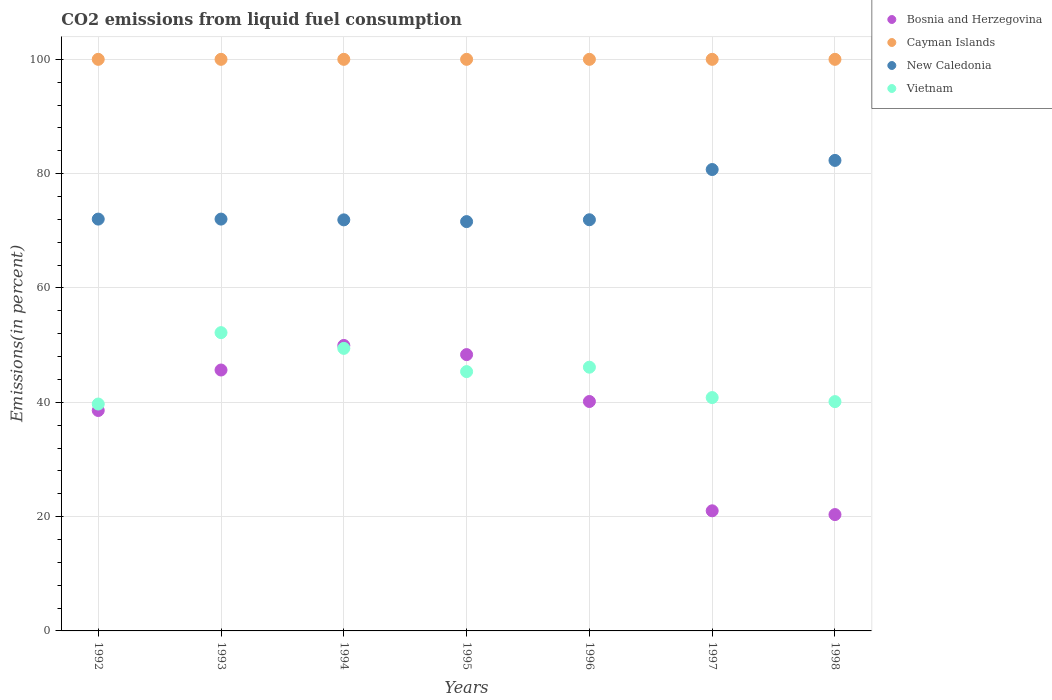Is the number of dotlines equal to the number of legend labels?
Offer a terse response. Yes. What is the total CO2 emitted in Bosnia and Herzegovina in 1996?
Your response must be concise. 40.14. Across all years, what is the maximum total CO2 emitted in Cayman Islands?
Provide a succinct answer. 100. Across all years, what is the minimum total CO2 emitted in Vietnam?
Your response must be concise. 39.7. In which year was the total CO2 emitted in New Caledonia maximum?
Provide a succinct answer. 1998. In which year was the total CO2 emitted in Cayman Islands minimum?
Provide a short and direct response. 1992. What is the total total CO2 emitted in New Caledonia in the graph?
Offer a very short reply. 522.6. What is the difference between the total CO2 emitted in New Caledonia in 1994 and that in 1995?
Make the answer very short. 0.3. What is the difference between the total CO2 emitted in Bosnia and Herzegovina in 1992 and the total CO2 emitted in Cayman Islands in 1996?
Provide a short and direct response. -61.44. What is the average total CO2 emitted in Bosnia and Herzegovina per year?
Your answer should be compact. 37.71. In the year 1992, what is the difference between the total CO2 emitted in New Caledonia and total CO2 emitted in Vietnam?
Keep it short and to the point. 32.35. In how many years, is the total CO2 emitted in Bosnia and Herzegovina greater than 72 %?
Provide a short and direct response. 0. What is the ratio of the total CO2 emitted in Vietnam in 1995 to that in 1996?
Offer a very short reply. 0.98. What is the difference between the highest and the second highest total CO2 emitted in Vietnam?
Make the answer very short. 2.75. What is the difference between the highest and the lowest total CO2 emitted in New Caledonia?
Offer a terse response. 10.71. Does the total CO2 emitted in New Caledonia monotonically increase over the years?
Your response must be concise. No. What is the difference between two consecutive major ticks on the Y-axis?
Offer a terse response. 20. How are the legend labels stacked?
Make the answer very short. Vertical. What is the title of the graph?
Offer a terse response. CO2 emissions from liquid fuel consumption. Does "Liechtenstein" appear as one of the legend labels in the graph?
Offer a very short reply. No. What is the label or title of the Y-axis?
Keep it short and to the point. Emissions(in percent). What is the Emissions(in percent) of Bosnia and Herzegovina in 1992?
Offer a very short reply. 38.56. What is the Emissions(in percent) of New Caledonia in 1992?
Provide a succinct answer. 72.05. What is the Emissions(in percent) of Vietnam in 1992?
Your answer should be compact. 39.7. What is the Emissions(in percent) of Bosnia and Herzegovina in 1993?
Keep it short and to the point. 45.65. What is the Emissions(in percent) of Cayman Islands in 1993?
Your response must be concise. 100. What is the Emissions(in percent) in New Caledonia in 1993?
Your answer should be very brief. 72.05. What is the Emissions(in percent) of Vietnam in 1993?
Give a very brief answer. 52.18. What is the Emissions(in percent) in Bosnia and Herzegovina in 1994?
Your response must be concise. 49.94. What is the Emissions(in percent) of New Caledonia in 1994?
Your answer should be very brief. 71.91. What is the Emissions(in percent) of Vietnam in 1994?
Offer a terse response. 49.43. What is the Emissions(in percent) in Bosnia and Herzegovina in 1995?
Ensure brevity in your answer.  48.34. What is the Emissions(in percent) in New Caledonia in 1995?
Give a very brief answer. 71.61. What is the Emissions(in percent) in Vietnam in 1995?
Your answer should be compact. 45.37. What is the Emissions(in percent) in Bosnia and Herzegovina in 1996?
Make the answer very short. 40.14. What is the Emissions(in percent) of Cayman Islands in 1996?
Keep it short and to the point. 100. What is the Emissions(in percent) of New Caledonia in 1996?
Make the answer very short. 71.93. What is the Emissions(in percent) in Vietnam in 1996?
Keep it short and to the point. 46.14. What is the Emissions(in percent) in Bosnia and Herzegovina in 1997?
Your answer should be compact. 21.01. What is the Emissions(in percent) of Cayman Islands in 1997?
Keep it short and to the point. 100. What is the Emissions(in percent) in New Caledonia in 1997?
Offer a terse response. 80.72. What is the Emissions(in percent) of Vietnam in 1997?
Ensure brevity in your answer.  40.82. What is the Emissions(in percent) of Bosnia and Herzegovina in 1998?
Provide a short and direct response. 20.35. What is the Emissions(in percent) of Cayman Islands in 1998?
Offer a very short reply. 100. What is the Emissions(in percent) of New Caledonia in 1998?
Your answer should be very brief. 82.32. What is the Emissions(in percent) of Vietnam in 1998?
Give a very brief answer. 40.12. Across all years, what is the maximum Emissions(in percent) in Bosnia and Herzegovina?
Keep it short and to the point. 49.94. Across all years, what is the maximum Emissions(in percent) of New Caledonia?
Offer a very short reply. 82.32. Across all years, what is the maximum Emissions(in percent) of Vietnam?
Your response must be concise. 52.18. Across all years, what is the minimum Emissions(in percent) of Bosnia and Herzegovina?
Your answer should be very brief. 20.35. Across all years, what is the minimum Emissions(in percent) in New Caledonia?
Give a very brief answer. 71.61. Across all years, what is the minimum Emissions(in percent) of Vietnam?
Your answer should be very brief. 39.7. What is the total Emissions(in percent) in Bosnia and Herzegovina in the graph?
Your response must be concise. 264. What is the total Emissions(in percent) in Cayman Islands in the graph?
Offer a terse response. 700. What is the total Emissions(in percent) in New Caledonia in the graph?
Ensure brevity in your answer.  522.6. What is the total Emissions(in percent) of Vietnam in the graph?
Your response must be concise. 313.76. What is the difference between the Emissions(in percent) of Bosnia and Herzegovina in 1992 and that in 1993?
Your response must be concise. -7.08. What is the difference between the Emissions(in percent) of Vietnam in 1992 and that in 1993?
Give a very brief answer. -12.49. What is the difference between the Emissions(in percent) of Bosnia and Herzegovina in 1992 and that in 1994?
Make the answer very short. -11.38. What is the difference between the Emissions(in percent) of New Caledonia in 1992 and that in 1994?
Offer a very short reply. 0.13. What is the difference between the Emissions(in percent) of Vietnam in 1992 and that in 1994?
Your answer should be very brief. -9.74. What is the difference between the Emissions(in percent) in Bosnia and Herzegovina in 1992 and that in 1995?
Provide a succinct answer. -9.78. What is the difference between the Emissions(in percent) in Cayman Islands in 1992 and that in 1995?
Give a very brief answer. 0. What is the difference between the Emissions(in percent) in New Caledonia in 1992 and that in 1995?
Ensure brevity in your answer.  0.44. What is the difference between the Emissions(in percent) of Vietnam in 1992 and that in 1995?
Offer a very short reply. -5.67. What is the difference between the Emissions(in percent) in Bosnia and Herzegovina in 1992 and that in 1996?
Your answer should be compact. -1.57. What is the difference between the Emissions(in percent) in New Caledonia in 1992 and that in 1996?
Your answer should be very brief. 0.12. What is the difference between the Emissions(in percent) in Vietnam in 1992 and that in 1996?
Provide a short and direct response. -6.44. What is the difference between the Emissions(in percent) of Bosnia and Herzegovina in 1992 and that in 1997?
Make the answer very short. 17.55. What is the difference between the Emissions(in percent) in New Caledonia in 1992 and that in 1997?
Offer a very short reply. -8.67. What is the difference between the Emissions(in percent) of Vietnam in 1992 and that in 1997?
Your response must be concise. -1.13. What is the difference between the Emissions(in percent) of Bosnia and Herzegovina in 1992 and that in 1998?
Your answer should be compact. 18.21. What is the difference between the Emissions(in percent) in Cayman Islands in 1992 and that in 1998?
Provide a succinct answer. 0. What is the difference between the Emissions(in percent) in New Caledonia in 1992 and that in 1998?
Provide a succinct answer. -10.27. What is the difference between the Emissions(in percent) of Vietnam in 1992 and that in 1998?
Offer a terse response. -0.42. What is the difference between the Emissions(in percent) in Bosnia and Herzegovina in 1993 and that in 1994?
Make the answer very short. -4.3. What is the difference between the Emissions(in percent) of New Caledonia in 1993 and that in 1994?
Your response must be concise. 0.13. What is the difference between the Emissions(in percent) of Vietnam in 1993 and that in 1994?
Keep it short and to the point. 2.75. What is the difference between the Emissions(in percent) in Bosnia and Herzegovina in 1993 and that in 1995?
Provide a short and direct response. -2.7. What is the difference between the Emissions(in percent) of Cayman Islands in 1993 and that in 1995?
Provide a short and direct response. 0. What is the difference between the Emissions(in percent) of New Caledonia in 1993 and that in 1995?
Provide a succinct answer. 0.44. What is the difference between the Emissions(in percent) in Vietnam in 1993 and that in 1995?
Keep it short and to the point. 6.82. What is the difference between the Emissions(in percent) in Bosnia and Herzegovina in 1993 and that in 1996?
Provide a succinct answer. 5.51. What is the difference between the Emissions(in percent) in New Caledonia in 1993 and that in 1996?
Make the answer very short. 0.12. What is the difference between the Emissions(in percent) of Vietnam in 1993 and that in 1996?
Keep it short and to the point. 6.04. What is the difference between the Emissions(in percent) of Bosnia and Herzegovina in 1993 and that in 1997?
Provide a short and direct response. 24.63. What is the difference between the Emissions(in percent) in Cayman Islands in 1993 and that in 1997?
Make the answer very short. 0. What is the difference between the Emissions(in percent) of New Caledonia in 1993 and that in 1997?
Offer a very short reply. -8.67. What is the difference between the Emissions(in percent) of Vietnam in 1993 and that in 1997?
Offer a very short reply. 11.36. What is the difference between the Emissions(in percent) in Bosnia and Herzegovina in 1993 and that in 1998?
Ensure brevity in your answer.  25.29. What is the difference between the Emissions(in percent) in New Caledonia in 1993 and that in 1998?
Your answer should be very brief. -10.27. What is the difference between the Emissions(in percent) of Vietnam in 1993 and that in 1998?
Give a very brief answer. 12.07. What is the difference between the Emissions(in percent) in Bosnia and Herzegovina in 1994 and that in 1995?
Provide a succinct answer. 1.6. What is the difference between the Emissions(in percent) of New Caledonia in 1994 and that in 1995?
Give a very brief answer. 0.3. What is the difference between the Emissions(in percent) of Vietnam in 1994 and that in 1995?
Provide a succinct answer. 4.07. What is the difference between the Emissions(in percent) of Bosnia and Herzegovina in 1994 and that in 1996?
Your answer should be compact. 9.81. What is the difference between the Emissions(in percent) in Cayman Islands in 1994 and that in 1996?
Ensure brevity in your answer.  0. What is the difference between the Emissions(in percent) of New Caledonia in 1994 and that in 1996?
Make the answer very short. -0.02. What is the difference between the Emissions(in percent) of Vietnam in 1994 and that in 1996?
Your answer should be compact. 3.29. What is the difference between the Emissions(in percent) of Bosnia and Herzegovina in 1994 and that in 1997?
Give a very brief answer. 28.93. What is the difference between the Emissions(in percent) in Cayman Islands in 1994 and that in 1997?
Your answer should be compact. 0. What is the difference between the Emissions(in percent) of New Caledonia in 1994 and that in 1997?
Your answer should be very brief. -8.81. What is the difference between the Emissions(in percent) in Vietnam in 1994 and that in 1997?
Provide a short and direct response. 8.61. What is the difference between the Emissions(in percent) of Bosnia and Herzegovina in 1994 and that in 1998?
Offer a very short reply. 29.59. What is the difference between the Emissions(in percent) in New Caledonia in 1994 and that in 1998?
Provide a short and direct response. -10.4. What is the difference between the Emissions(in percent) in Vietnam in 1994 and that in 1998?
Offer a very short reply. 9.32. What is the difference between the Emissions(in percent) in Bosnia and Herzegovina in 1995 and that in 1996?
Ensure brevity in your answer.  8.2. What is the difference between the Emissions(in percent) in Cayman Islands in 1995 and that in 1996?
Offer a very short reply. 0. What is the difference between the Emissions(in percent) of New Caledonia in 1995 and that in 1996?
Give a very brief answer. -0.32. What is the difference between the Emissions(in percent) in Vietnam in 1995 and that in 1996?
Your response must be concise. -0.77. What is the difference between the Emissions(in percent) of Bosnia and Herzegovina in 1995 and that in 1997?
Offer a very short reply. 27.33. What is the difference between the Emissions(in percent) in New Caledonia in 1995 and that in 1997?
Give a very brief answer. -9.11. What is the difference between the Emissions(in percent) in Vietnam in 1995 and that in 1997?
Your answer should be compact. 4.54. What is the difference between the Emissions(in percent) of Bosnia and Herzegovina in 1995 and that in 1998?
Make the answer very short. 27.99. What is the difference between the Emissions(in percent) of New Caledonia in 1995 and that in 1998?
Your answer should be very brief. -10.71. What is the difference between the Emissions(in percent) in Vietnam in 1995 and that in 1998?
Your response must be concise. 5.25. What is the difference between the Emissions(in percent) of Bosnia and Herzegovina in 1996 and that in 1997?
Offer a terse response. 19.12. What is the difference between the Emissions(in percent) in New Caledonia in 1996 and that in 1997?
Your response must be concise. -8.79. What is the difference between the Emissions(in percent) of Vietnam in 1996 and that in 1997?
Offer a very short reply. 5.31. What is the difference between the Emissions(in percent) in Bosnia and Herzegovina in 1996 and that in 1998?
Ensure brevity in your answer.  19.78. What is the difference between the Emissions(in percent) in New Caledonia in 1996 and that in 1998?
Ensure brevity in your answer.  -10.38. What is the difference between the Emissions(in percent) of Vietnam in 1996 and that in 1998?
Your response must be concise. 6.02. What is the difference between the Emissions(in percent) of Bosnia and Herzegovina in 1997 and that in 1998?
Make the answer very short. 0.66. What is the difference between the Emissions(in percent) of Cayman Islands in 1997 and that in 1998?
Offer a terse response. 0. What is the difference between the Emissions(in percent) of New Caledonia in 1997 and that in 1998?
Make the answer very short. -1.59. What is the difference between the Emissions(in percent) of Vietnam in 1997 and that in 1998?
Ensure brevity in your answer.  0.71. What is the difference between the Emissions(in percent) in Bosnia and Herzegovina in 1992 and the Emissions(in percent) in Cayman Islands in 1993?
Your answer should be compact. -61.44. What is the difference between the Emissions(in percent) of Bosnia and Herzegovina in 1992 and the Emissions(in percent) of New Caledonia in 1993?
Your response must be concise. -33.49. What is the difference between the Emissions(in percent) of Bosnia and Herzegovina in 1992 and the Emissions(in percent) of Vietnam in 1993?
Offer a terse response. -13.62. What is the difference between the Emissions(in percent) in Cayman Islands in 1992 and the Emissions(in percent) in New Caledonia in 1993?
Offer a terse response. 27.95. What is the difference between the Emissions(in percent) of Cayman Islands in 1992 and the Emissions(in percent) of Vietnam in 1993?
Offer a very short reply. 47.82. What is the difference between the Emissions(in percent) of New Caledonia in 1992 and the Emissions(in percent) of Vietnam in 1993?
Make the answer very short. 19.87. What is the difference between the Emissions(in percent) of Bosnia and Herzegovina in 1992 and the Emissions(in percent) of Cayman Islands in 1994?
Keep it short and to the point. -61.44. What is the difference between the Emissions(in percent) in Bosnia and Herzegovina in 1992 and the Emissions(in percent) in New Caledonia in 1994?
Ensure brevity in your answer.  -33.35. What is the difference between the Emissions(in percent) of Bosnia and Herzegovina in 1992 and the Emissions(in percent) of Vietnam in 1994?
Offer a very short reply. -10.87. What is the difference between the Emissions(in percent) of Cayman Islands in 1992 and the Emissions(in percent) of New Caledonia in 1994?
Give a very brief answer. 28.09. What is the difference between the Emissions(in percent) in Cayman Islands in 1992 and the Emissions(in percent) in Vietnam in 1994?
Your answer should be very brief. 50.57. What is the difference between the Emissions(in percent) in New Caledonia in 1992 and the Emissions(in percent) in Vietnam in 1994?
Provide a short and direct response. 22.62. What is the difference between the Emissions(in percent) of Bosnia and Herzegovina in 1992 and the Emissions(in percent) of Cayman Islands in 1995?
Offer a very short reply. -61.44. What is the difference between the Emissions(in percent) in Bosnia and Herzegovina in 1992 and the Emissions(in percent) in New Caledonia in 1995?
Offer a very short reply. -33.05. What is the difference between the Emissions(in percent) of Bosnia and Herzegovina in 1992 and the Emissions(in percent) of Vietnam in 1995?
Your response must be concise. -6.8. What is the difference between the Emissions(in percent) of Cayman Islands in 1992 and the Emissions(in percent) of New Caledonia in 1995?
Ensure brevity in your answer.  28.39. What is the difference between the Emissions(in percent) in Cayman Islands in 1992 and the Emissions(in percent) in Vietnam in 1995?
Provide a succinct answer. 54.63. What is the difference between the Emissions(in percent) in New Caledonia in 1992 and the Emissions(in percent) in Vietnam in 1995?
Offer a very short reply. 26.68. What is the difference between the Emissions(in percent) in Bosnia and Herzegovina in 1992 and the Emissions(in percent) in Cayman Islands in 1996?
Offer a very short reply. -61.44. What is the difference between the Emissions(in percent) in Bosnia and Herzegovina in 1992 and the Emissions(in percent) in New Caledonia in 1996?
Your answer should be very brief. -33.37. What is the difference between the Emissions(in percent) in Bosnia and Herzegovina in 1992 and the Emissions(in percent) in Vietnam in 1996?
Offer a very short reply. -7.58. What is the difference between the Emissions(in percent) in Cayman Islands in 1992 and the Emissions(in percent) in New Caledonia in 1996?
Keep it short and to the point. 28.07. What is the difference between the Emissions(in percent) in Cayman Islands in 1992 and the Emissions(in percent) in Vietnam in 1996?
Provide a short and direct response. 53.86. What is the difference between the Emissions(in percent) in New Caledonia in 1992 and the Emissions(in percent) in Vietnam in 1996?
Your answer should be compact. 25.91. What is the difference between the Emissions(in percent) of Bosnia and Herzegovina in 1992 and the Emissions(in percent) of Cayman Islands in 1997?
Offer a very short reply. -61.44. What is the difference between the Emissions(in percent) of Bosnia and Herzegovina in 1992 and the Emissions(in percent) of New Caledonia in 1997?
Offer a terse response. -42.16. What is the difference between the Emissions(in percent) in Bosnia and Herzegovina in 1992 and the Emissions(in percent) in Vietnam in 1997?
Ensure brevity in your answer.  -2.26. What is the difference between the Emissions(in percent) of Cayman Islands in 1992 and the Emissions(in percent) of New Caledonia in 1997?
Keep it short and to the point. 19.28. What is the difference between the Emissions(in percent) in Cayman Islands in 1992 and the Emissions(in percent) in Vietnam in 1997?
Keep it short and to the point. 59.18. What is the difference between the Emissions(in percent) in New Caledonia in 1992 and the Emissions(in percent) in Vietnam in 1997?
Provide a succinct answer. 31.23. What is the difference between the Emissions(in percent) of Bosnia and Herzegovina in 1992 and the Emissions(in percent) of Cayman Islands in 1998?
Your response must be concise. -61.44. What is the difference between the Emissions(in percent) in Bosnia and Herzegovina in 1992 and the Emissions(in percent) in New Caledonia in 1998?
Ensure brevity in your answer.  -43.75. What is the difference between the Emissions(in percent) in Bosnia and Herzegovina in 1992 and the Emissions(in percent) in Vietnam in 1998?
Make the answer very short. -1.55. What is the difference between the Emissions(in percent) in Cayman Islands in 1992 and the Emissions(in percent) in New Caledonia in 1998?
Offer a terse response. 17.68. What is the difference between the Emissions(in percent) of Cayman Islands in 1992 and the Emissions(in percent) of Vietnam in 1998?
Offer a very short reply. 59.88. What is the difference between the Emissions(in percent) of New Caledonia in 1992 and the Emissions(in percent) of Vietnam in 1998?
Your response must be concise. 31.93. What is the difference between the Emissions(in percent) of Bosnia and Herzegovina in 1993 and the Emissions(in percent) of Cayman Islands in 1994?
Offer a terse response. -54.35. What is the difference between the Emissions(in percent) of Bosnia and Herzegovina in 1993 and the Emissions(in percent) of New Caledonia in 1994?
Offer a very short reply. -26.27. What is the difference between the Emissions(in percent) of Bosnia and Herzegovina in 1993 and the Emissions(in percent) of Vietnam in 1994?
Give a very brief answer. -3.79. What is the difference between the Emissions(in percent) in Cayman Islands in 1993 and the Emissions(in percent) in New Caledonia in 1994?
Keep it short and to the point. 28.09. What is the difference between the Emissions(in percent) of Cayman Islands in 1993 and the Emissions(in percent) of Vietnam in 1994?
Provide a short and direct response. 50.57. What is the difference between the Emissions(in percent) in New Caledonia in 1993 and the Emissions(in percent) in Vietnam in 1994?
Your answer should be compact. 22.62. What is the difference between the Emissions(in percent) of Bosnia and Herzegovina in 1993 and the Emissions(in percent) of Cayman Islands in 1995?
Provide a short and direct response. -54.35. What is the difference between the Emissions(in percent) of Bosnia and Herzegovina in 1993 and the Emissions(in percent) of New Caledonia in 1995?
Your response must be concise. -25.96. What is the difference between the Emissions(in percent) of Bosnia and Herzegovina in 1993 and the Emissions(in percent) of Vietnam in 1995?
Make the answer very short. 0.28. What is the difference between the Emissions(in percent) of Cayman Islands in 1993 and the Emissions(in percent) of New Caledonia in 1995?
Your answer should be compact. 28.39. What is the difference between the Emissions(in percent) in Cayman Islands in 1993 and the Emissions(in percent) in Vietnam in 1995?
Provide a short and direct response. 54.63. What is the difference between the Emissions(in percent) of New Caledonia in 1993 and the Emissions(in percent) of Vietnam in 1995?
Provide a short and direct response. 26.68. What is the difference between the Emissions(in percent) of Bosnia and Herzegovina in 1993 and the Emissions(in percent) of Cayman Islands in 1996?
Ensure brevity in your answer.  -54.35. What is the difference between the Emissions(in percent) of Bosnia and Herzegovina in 1993 and the Emissions(in percent) of New Caledonia in 1996?
Offer a very short reply. -26.29. What is the difference between the Emissions(in percent) of Bosnia and Herzegovina in 1993 and the Emissions(in percent) of Vietnam in 1996?
Offer a terse response. -0.49. What is the difference between the Emissions(in percent) in Cayman Islands in 1993 and the Emissions(in percent) in New Caledonia in 1996?
Offer a terse response. 28.07. What is the difference between the Emissions(in percent) of Cayman Islands in 1993 and the Emissions(in percent) of Vietnam in 1996?
Keep it short and to the point. 53.86. What is the difference between the Emissions(in percent) in New Caledonia in 1993 and the Emissions(in percent) in Vietnam in 1996?
Give a very brief answer. 25.91. What is the difference between the Emissions(in percent) in Bosnia and Herzegovina in 1993 and the Emissions(in percent) in Cayman Islands in 1997?
Keep it short and to the point. -54.35. What is the difference between the Emissions(in percent) of Bosnia and Herzegovina in 1993 and the Emissions(in percent) of New Caledonia in 1997?
Provide a succinct answer. -35.08. What is the difference between the Emissions(in percent) of Bosnia and Herzegovina in 1993 and the Emissions(in percent) of Vietnam in 1997?
Your response must be concise. 4.82. What is the difference between the Emissions(in percent) of Cayman Islands in 1993 and the Emissions(in percent) of New Caledonia in 1997?
Ensure brevity in your answer.  19.28. What is the difference between the Emissions(in percent) in Cayman Islands in 1993 and the Emissions(in percent) in Vietnam in 1997?
Your answer should be very brief. 59.18. What is the difference between the Emissions(in percent) in New Caledonia in 1993 and the Emissions(in percent) in Vietnam in 1997?
Make the answer very short. 31.23. What is the difference between the Emissions(in percent) in Bosnia and Herzegovina in 1993 and the Emissions(in percent) in Cayman Islands in 1998?
Offer a terse response. -54.35. What is the difference between the Emissions(in percent) in Bosnia and Herzegovina in 1993 and the Emissions(in percent) in New Caledonia in 1998?
Keep it short and to the point. -36.67. What is the difference between the Emissions(in percent) in Bosnia and Herzegovina in 1993 and the Emissions(in percent) in Vietnam in 1998?
Offer a terse response. 5.53. What is the difference between the Emissions(in percent) of Cayman Islands in 1993 and the Emissions(in percent) of New Caledonia in 1998?
Give a very brief answer. 17.68. What is the difference between the Emissions(in percent) in Cayman Islands in 1993 and the Emissions(in percent) in Vietnam in 1998?
Your answer should be very brief. 59.88. What is the difference between the Emissions(in percent) of New Caledonia in 1993 and the Emissions(in percent) of Vietnam in 1998?
Your answer should be compact. 31.93. What is the difference between the Emissions(in percent) of Bosnia and Herzegovina in 1994 and the Emissions(in percent) of Cayman Islands in 1995?
Offer a very short reply. -50.06. What is the difference between the Emissions(in percent) in Bosnia and Herzegovina in 1994 and the Emissions(in percent) in New Caledonia in 1995?
Your response must be concise. -21.67. What is the difference between the Emissions(in percent) in Bosnia and Herzegovina in 1994 and the Emissions(in percent) in Vietnam in 1995?
Offer a very short reply. 4.58. What is the difference between the Emissions(in percent) in Cayman Islands in 1994 and the Emissions(in percent) in New Caledonia in 1995?
Your answer should be very brief. 28.39. What is the difference between the Emissions(in percent) in Cayman Islands in 1994 and the Emissions(in percent) in Vietnam in 1995?
Give a very brief answer. 54.63. What is the difference between the Emissions(in percent) in New Caledonia in 1994 and the Emissions(in percent) in Vietnam in 1995?
Keep it short and to the point. 26.55. What is the difference between the Emissions(in percent) of Bosnia and Herzegovina in 1994 and the Emissions(in percent) of Cayman Islands in 1996?
Provide a succinct answer. -50.06. What is the difference between the Emissions(in percent) of Bosnia and Herzegovina in 1994 and the Emissions(in percent) of New Caledonia in 1996?
Offer a very short reply. -21.99. What is the difference between the Emissions(in percent) of Bosnia and Herzegovina in 1994 and the Emissions(in percent) of Vietnam in 1996?
Offer a very short reply. 3.8. What is the difference between the Emissions(in percent) of Cayman Islands in 1994 and the Emissions(in percent) of New Caledonia in 1996?
Your response must be concise. 28.07. What is the difference between the Emissions(in percent) of Cayman Islands in 1994 and the Emissions(in percent) of Vietnam in 1996?
Make the answer very short. 53.86. What is the difference between the Emissions(in percent) of New Caledonia in 1994 and the Emissions(in percent) of Vietnam in 1996?
Ensure brevity in your answer.  25.78. What is the difference between the Emissions(in percent) in Bosnia and Herzegovina in 1994 and the Emissions(in percent) in Cayman Islands in 1997?
Offer a very short reply. -50.06. What is the difference between the Emissions(in percent) in Bosnia and Herzegovina in 1994 and the Emissions(in percent) in New Caledonia in 1997?
Provide a succinct answer. -30.78. What is the difference between the Emissions(in percent) in Bosnia and Herzegovina in 1994 and the Emissions(in percent) in Vietnam in 1997?
Make the answer very short. 9.12. What is the difference between the Emissions(in percent) of Cayman Islands in 1994 and the Emissions(in percent) of New Caledonia in 1997?
Provide a succinct answer. 19.28. What is the difference between the Emissions(in percent) in Cayman Islands in 1994 and the Emissions(in percent) in Vietnam in 1997?
Your response must be concise. 59.18. What is the difference between the Emissions(in percent) of New Caledonia in 1994 and the Emissions(in percent) of Vietnam in 1997?
Your answer should be very brief. 31.09. What is the difference between the Emissions(in percent) of Bosnia and Herzegovina in 1994 and the Emissions(in percent) of Cayman Islands in 1998?
Make the answer very short. -50.06. What is the difference between the Emissions(in percent) of Bosnia and Herzegovina in 1994 and the Emissions(in percent) of New Caledonia in 1998?
Provide a short and direct response. -32.37. What is the difference between the Emissions(in percent) in Bosnia and Herzegovina in 1994 and the Emissions(in percent) in Vietnam in 1998?
Provide a short and direct response. 9.83. What is the difference between the Emissions(in percent) in Cayman Islands in 1994 and the Emissions(in percent) in New Caledonia in 1998?
Your response must be concise. 17.68. What is the difference between the Emissions(in percent) of Cayman Islands in 1994 and the Emissions(in percent) of Vietnam in 1998?
Your answer should be very brief. 59.88. What is the difference between the Emissions(in percent) of New Caledonia in 1994 and the Emissions(in percent) of Vietnam in 1998?
Your response must be concise. 31.8. What is the difference between the Emissions(in percent) of Bosnia and Herzegovina in 1995 and the Emissions(in percent) of Cayman Islands in 1996?
Provide a short and direct response. -51.66. What is the difference between the Emissions(in percent) of Bosnia and Herzegovina in 1995 and the Emissions(in percent) of New Caledonia in 1996?
Give a very brief answer. -23.59. What is the difference between the Emissions(in percent) of Bosnia and Herzegovina in 1995 and the Emissions(in percent) of Vietnam in 1996?
Your answer should be very brief. 2.2. What is the difference between the Emissions(in percent) in Cayman Islands in 1995 and the Emissions(in percent) in New Caledonia in 1996?
Provide a succinct answer. 28.07. What is the difference between the Emissions(in percent) in Cayman Islands in 1995 and the Emissions(in percent) in Vietnam in 1996?
Your answer should be compact. 53.86. What is the difference between the Emissions(in percent) in New Caledonia in 1995 and the Emissions(in percent) in Vietnam in 1996?
Your response must be concise. 25.47. What is the difference between the Emissions(in percent) of Bosnia and Herzegovina in 1995 and the Emissions(in percent) of Cayman Islands in 1997?
Keep it short and to the point. -51.66. What is the difference between the Emissions(in percent) in Bosnia and Herzegovina in 1995 and the Emissions(in percent) in New Caledonia in 1997?
Your response must be concise. -32.38. What is the difference between the Emissions(in percent) in Bosnia and Herzegovina in 1995 and the Emissions(in percent) in Vietnam in 1997?
Make the answer very short. 7.52. What is the difference between the Emissions(in percent) of Cayman Islands in 1995 and the Emissions(in percent) of New Caledonia in 1997?
Provide a short and direct response. 19.28. What is the difference between the Emissions(in percent) in Cayman Islands in 1995 and the Emissions(in percent) in Vietnam in 1997?
Your answer should be very brief. 59.18. What is the difference between the Emissions(in percent) of New Caledonia in 1995 and the Emissions(in percent) of Vietnam in 1997?
Make the answer very short. 30.79. What is the difference between the Emissions(in percent) in Bosnia and Herzegovina in 1995 and the Emissions(in percent) in Cayman Islands in 1998?
Your answer should be compact. -51.66. What is the difference between the Emissions(in percent) of Bosnia and Herzegovina in 1995 and the Emissions(in percent) of New Caledonia in 1998?
Give a very brief answer. -33.97. What is the difference between the Emissions(in percent) of Bosnia and Herzegovina in 1995 and the Emissions(in percent) of Vietnam in 1998?
Make the answer very short. 8.22. What is the difference between the Emissions(in percent) in Cayman Islands in 1995 and the Emissions(in percent) in New Caledonia in 1998?
Give a very brief answer. 17.68. What is the difference between the Emissions(in percent) in Cayman Islands in 1995 and the Emissions(in percent) in Vietnam in 1998?
Your answer should be very brief. 59.88. What is the difference between the Emissions(in percent) in New Caledonia in 1995 and the Emissions(in percent) in Vietnam in 1998?
Provide a short and direct response. 31.49. What is the difference between the Emissions(in percent) of Bosnia and Herzegovina in 1996 and the Emissions(in percent) of Cayman Islands in 1997?
Keep it short and to the point. -59.86. What is the difference between the Emissions(in percent) of Bosnia and Herzegovina in 1996 and the Emissions(in percent) of New Caledonia in 1997?
Your answer should be very brief. -40.59. What is the difference between the Emissions(in percent) of Bosnia and Herzegovina in 1996 and the Emissions(in percent) of Vietnam in 1997?
Give a very brief answer. -0.69. What is the difference between the Emissions(in percent) in Cayman Islands in 1996 and the Emissions(in percent) in New Caledonia in 1997?
Provide a short and direct response. 19.28. What is the difference between the Emissions(in percent) in Cayman Islands in 1996 and the Emissions(in percent) in Vietnam in 1997?
Your answer should be compact. 59.18. What is the difference between the Emissions(in percent) in New Caledonia in 1996 and the Emissions(in percent) in Vietnam in 1997?
Offer a very short reply. 31.11. What is the difference between the Emissions(in percent) in Bosnia and Herzegovina in 1996 and the Emissions(in percent) in Cayman Islands in 1998?
Keep it short and to the point. -59.86. What is the difference between the Emissions(in percent) of Bosnia and Herzegovina in 1996 and the Emissions(in percent) of New Caledonia in 1998?
Keep it short and to the point. -42.18. What is the difference between the Emissions(in percent) of Bosnia and Herzegovina in 1996 and the Emissions(in percent) of Vietnam in 1998?
Keep it short and to the point. 0.02. What is the difference between the Emissions(in percent) of Cayman Islands in 1996 and the Emissions(in percent) of New Caledonia in 1998?
Provide a succinct answer. 17.68. What is the difference between the Emissions(in percent) of Cayman Islands in 1996 and the Emissions(in percent) of Vietnam in 1998?
Your answer should be compact. 59.88. What is the difference between the Emissions(in percent) of New Caledonia in 1996 and the Emissions(in percent) of Vietnam in 1998?
Keep it short and to the point. 31.82. What is the difference between the Emissions(in percent) in Bosnia and Herzegovina in 1997 and the Emissions(in percent) in Cayman Islands in 1998?
Your response must be concise. -78.99. What is the difference between the Emissions(in percent) of Bosnia and Herzegovina in 1997 and the Emissions(in percent) of New Caledonia in 1998?
Ensure brevity in your answer.  -61.3. What is the difference between the Emissions(in percent) of Bosnia and Herzegovina in 1997 and the Emissions(in percent) of Vietnam in 1998?
Provide a short and direct response. -19.1. What is the difference between the Emissions(in percent) in Cayman Islands in 1997 and the Emissions(in percent) in New Caledonia in 1998?
Your response must be concise. 17.68. What is the difference between the Emissions(in percent) in Cayman Islands in 1997 and the Emissions(in percent) in Vietnam in 1998?
Your answer should be very brief. 59.88. What is the difference between the Emissions(in percent) in New Caledonia in 1997 and the Emissions(in percent) in Vietnam in 1998?
Your answer should be very brief. 40.61. What is the average Emissions(in percent) in Bosnia and Herzegovina per year?
Your answer should be very brief. 37.71. What is the average Emissions(in percent) of New Caledonia per year?
Your response must be concise. 74.66. What is the average Emissions(in percent) of Vietnam per year?
Offer a very short reply. 44.82. In the year 1992, what is the difference between the Emissions(in percent) of Bosnia and Herzegovina and Emissions(in percent) of Cayman Islands?
Give a very brief answer. -61.44. In the year 1992, what is the difference between the Emissions(in percent) of Bosnia and Herzegovina and Emissions(in percent) of New Caledonia?
Make the answer very short. -33.49. In the year 1992, what is the difference between the Emissions(in percent) of Bosnia and Herzegovina and Emissions(in percent) of Vietnam?
Provide a short and direct response. -1.13. In the year 1992, what is the difference between the Emissions(in percent) in Cayman Islands and Emissions(in percent) in New Caledonia?
Provide a succinct answer. 27.95. In the year 1992, what is the difference between the Emissions(in percent) in Cayman Islands and Emissions(in percent) in Vietnam?
Make the answer very short. 60.3. In the year 1992, what is the difference between the Emissions(in percent) in New Caledonia and Emissions(in percent) in Vietnam?
Give a very brief answer. 32.35. In the year 1993, what is the difference between the Emissions(in percent) of Bosnia and Herzegovina and Emissions(in percent) of Cayman Islands?
Offer a very short reply. -54.35. In the year 1993, what is the difference between the Emissions(in percent) in Bosnia and Herzegovina and Emissions(in percent) in New Caledonia?
Provide a succinct answer. -26.4. In the year 1993, what is the difference between the Emissions(in percent) in Bosnia and Herzegovina and Emissions(in percent) in Vietnam?
Offer a terse response. -6.54. In the year 1993, what is the difference between the Emissions(in percent) of Cayman Islands and Emissions(in percent) of New Caledonia?
Provide a succinct answer. 27.95. In the year 1993, what is the difference between the Emissions(in percent) of Cayman Islands and Emissions(in percent) of Vietnam?
Provide a succinct answer. 47.82. In the year 1993, what is the difference between the Emissions(in percent) of New Caledonia and Emissions(in percent) of Vietnam?
Ensure brevity in your answer.  19.87. In the year 1994, what is the difference between the Emissions(in percent) in Bosnia and Herzegovina and Emissions(in percent) in Cayman Islands?
Your answer should be compact. -50.06. In the year 1994, what is the difference between the Emissions(in percent) in Bosnia and Herzegovina and Emissions(in percent) in New Caledonia?
Your answer should be very brief. -21.97. In the year 1994, what is the difference between the Emissions(in percent) in Bosnia and Herzegovina and Emissions(in percent) in Vietnam?
Offer a very short reply. 0.51. In the year 1994, what is the difference between the Emissions(in percent) in Cayman Islands and Emissions(in percent) in New Caledonia?
Provide a short and direct response. 28.09. In the year 1994, what is the difference between the Emissions(in percent) of Cayman Islands and Emissions(in percent) of Vietnam?
Make the answer very short. 50.57. In the year 1994, what is the difference between the Emissions(in percent) of New Caledonia and Emissions(in percent) of Vietnam?
Your answer should be compact. 22.48. In the year 1995, what is the difference between the Emissions(in percent) in Bosnia and Herzegovina and Emissions(in percent) in Cayman Islands?
Provide a short and direct response. -51.66. In the year 1995, what is the difference between the Emissions(in percent) in Bosnia and Herzegovina and Emissions(in percent) in New Caledonia?
Keep it short and to the point. -23.27. In the year 1995, what is the difference between the Emissions(in percent) of Bosnia and Herzegovina and Emissions(in percent) of Vietnam?
Provide a short and direct response. 2.97. In the year 1995, what is the difference between the Emissions(in percent) of Cayman Islands and Emissions(in percent) of New Caledonia?
Your response must be concise. 28.39. In the year 1995, what is the difference between the Emissions(in percent) in Cayman Islands and Emissions(in percent) in Vietnam?
Your answer should be compact. 54.63. In the year 1995, what is the difference between the Emissions(in percent) in New Caledonia and Emissions(in percent) in Vietnam?
Make the answer very short. 26.24. In the year 1996, what is the difference between the Emissions(in percent) in Bosnia and Herzegovina and Emissions(in percent) in Cayman Islands?
Your answer should be very brief. -59.86. In the year 1996, what is the difference between the Emissions(in percent) of Bosnia and Herzegovina and Emissions(in percent) of New Caledonia?
Ensure brevity in your answer.  -31.8. In the year 1996, what is the difference between the Emissions(in percent) in Bosnia and Herzegovina and Emissions(in percent) in Vietnam?
Your answer should be compact. -6. In the year 1996, what is the difference between the Emissions(in percent) in Cayman Islands and Emissions(in percent) in New Caledonia?
Offer a terse response. 28.07. In the year 1996, what is the difference between the Emissions(in percent) of Cayman Islands and Emissions(in percent) of Vietnam?
Keep it short and to the point. 53.86. In the year 1996, what is the difference between the Emissions(in percent) of New Caledonia and Emissions(in percent) of Vietnam?
Ensure brevity in your answer.  25.79. In the year 1997, what is the difference between the Emissions(in percent) of Bosnia and Herzegovina and Emissions(in percent) of Cayman Islands?
Keep it short and to the point. -78.99. In the year 1997, what is the difference between the Emissions(in percent) of Bosnia and Herzegovina and Emissions(in percent) of New Caledonia?
Your answer should be compact. -59.71. In the year 1997, what is the difference between the Emissions(in percent) of Bosnia and Herzegovina and Emissions(in percent) of Vietnam?
Ensure brevity in your answer.  -19.81. In the year 1997, what is the difference between the Emissions(in percent) in Cayman Islands and Emissions(in percent) in New Caledonia?
Offer a very short reply. 19.28. In the year 1997, what is the difference between the Emissions(in percent) in Cayman Islands and Emissions(in percent) in Vietnam?
Offer a very short reply. 59.18. In the year 1997, what is the difference between the Emissions(in percent) of New Caledonia and Emissions(in percent) of Vietnam?
Offer a terse response. 39.9. In the year 1998, what is the difference between the Emissions(in percent) of Bosnia and Herzegovina and Emissions(in percent) of Cayman Islands?
Ensure brevity in your answer.  -79.65. In the year 1998, what is the difference between the Emissions(in percent) of Bosnia and Herzegovina and Emissions(in percent) of New Caledonia?
Offer a very short reply. -61.96. In the year 1998, what is the difference between the Emissions(in percent) of Bosnia and Herzegovina and Emissions(in percent) of Vietnam?
Keep it short and to the point. -19.76. In the year 1998, what is the difference between the Emissions(in percent) in Cayman Islands and Emissions(in percent) in New Caledonia?
Provide a short and direct response. 17.68. In the year 1998, what is the difference between the Emissions(in percent) of Cayman Islands and Emissions(in percent) of Vietnam?
Offer a very short reply. 59.88. In the year 1998, what is the difference between the Emissions(in percent) in New Caledonia and Emissions(in percent) in Vietnam?
Ensure brevity in your answer.  42.2. What is the ratio of the Emissions(in percent) of Bosnia and Herzegovina in 1992 to that in 1993?
Your response must be concise. 0.84. What is the ratio of the Emissions(in percent) of Cayman Islands in 1992 to that in 1993?
Give a very brief answer. 1. What is the ratio of the Emissions(in percent) in Vietnam in 1992 to that in 1993?
Provide a succinct answer. 0.76. What is the ratio of the Emissions(in percent) in Bosnia and Herzegovina in 1992 to that in 1994?
Make the answer very short. 0.77. What is the ratio of the Emissions(in percent) in New Caledonia in 1992 to that in 1994?
Provide a succinct answer. 1. What is the ratio of the Emissions(in percent) of Vietnam in 1992 to that in 1994?
Your response must be concise. 0.8. What is the ratio of the Emissions(in percent) of Bosnia and Herzegovina in 1992 to that in 1995?
Ensure brevity in your answer.  0.8. What is the ratio of the Emissions(in percent) of Vietnam in 1992 to that in 1995?
Your response must be concise. 0.88. What is the ratio of the Emissions(in percent) of Bosnia and Herzegovina in 1992 to that in 1996?
Offer a terse response. 0.96. What is the ratio of the Emissions(in percent) in New Caledonia in 1992 to that in 1996?
Your answer should be compact. 1. What is the ratio of the Emissions(in percent) of Vietnam in 1992 to that in 1996?
Keep it short and to the point. 0.86. What is the ratio of the Emissions(in percent) of Bosnia and Herzegovina in 1992 to that in 1997?
Make the answer very short. 1.84. What is the ratio of the Emissions(in percent) in New Caledonia in 1992 to that in 1997?
Your answer should be compact. 0.89. What is the ratio of the Emissions(in percent) in Vietnam in 1992 to that in 1997?
Offer a terse response. 0.97. What is the ratio of the Emissions(in percent) of Bosnia and Herzegovina in 1992 to that in 1998?
Offer a very short reply. 1.89. What is the ratio of the Emissions(in percent) of Cayman Islands in 1992 to that in 1998?
Offer a very short reply. 1. What is the ratio of the Emissions(in percent) of New Caledonia in 1992 to that in 1998?
Give a very brief answer. 0.88. What is the ratio of the Emissions(in percent) in Bosnia and Herzegovina in 1993 to that in 1994?
Keep it short and to the point. 0.91. What is the ratio of the Emissions(in percent) of Vietnam in 1993 to that in 1994?
Provide a short and direct response. 1.06. What is the ratio of the Emissions(in percent) of Bosnia and Herzegovina in 1993 to that in 1995?
Ensure brevity in your answer.  0.94. What is the ratio of the Emissions(in percent) of Vietnam in 1993 to that in 1995?
Offer a very short reply. 1.15. What is the ratio of the Emissions(in percent) of Bosnia and Herzegovina in 1993 to that in 1996?
Give a very brief answer. 1.14. What is the ratio of the Emissions(in percent) of Cayman Islands in 1993 to that in 1996?
Ensure brevity in your answer.  1. What is the ratio of the Emissions(in percent) of New Caledonia in 1993 to that in 1996?
Your answer should be compact. 1. What is the ratio of the Emissions(in percent) in Vietnam in 1993 to that in 1996?
Give a very brief answer. 1.13. What is the ratio of the Emissions(in percent) of Bosnia and Herzegovina in 1993 to that in 1997?
Ensure brevity in your answer.  2.17. What is the ratio of the Emissions(in percent) in Cayman Islands in 1993 to that in 1997?
Your answer should be compact. 1. What is the ratio of the Emissions(in percent) in New Caledonia in 1993 to that in 1997?
Make the answer very short. 0.89. What is the ratio of the Emissions(in percent) in Vietnam in 1993 to that in 1997?
Provide a short and direct response. 1.28. What is the ratio of the Emissions(in percent) of Bosnia and Herzegovina in 1993 to that in 1998?
Keep it short and to the point. 2.24. What is the ratio of the Emissions(in percent) in New Caledonia in 1993 to that in 1998?
Offer a terse response. 0.88. What is the ratio of the Emissions(in percent) of Vietnam in 1993 to that in 1998?
Give a very brief answer. 1.3. What is the ratio of the Emissions(in percent) in Bosnia and Herzegovina in 1994 to that in 1995?
Keep it short and to the point. 1.03. What is the ratio of the Emissions(in percent) in Cayman Islands in 1994 to that in 1995?
Your response must be concise. 1. What is the ratio of the Emissions(in percent) of New Caledonia in 1994 to that in 1995?
Give a very brief answer. 1. What is the ratio of the Emissions(in percent) of Vietnam in 1994 to that in 1995?
Provide a succinct answer. 1.09. What is the ratio of the Emissions(in percent) of Bosnia and Herzegovina in 1994 to that in 1996?
Give a very brief answer. 1.24. What is the ratio of the Emissions(in percent) in Cayman Islands in 1994 to that in 1996?
Provide a succinct answer. 1. What is the ratio of the Emissions(in percent) of New Caledonia in 1994 to that in 1996?
Offer a terse response. 1. What is the ratio of the Emissions(in percent) of Vietnam in 1994 to that in 1996?
Your response must be concise. 1.07. What is the ratio of the Emissions(in percent) of Bosnia and Herzegovina in 1994 to that in 1997?
Provide a succinct answer. 2.38. What is the ratio of the Emissions(in percent) of Cayman Islands in 1994 to that in 1997?
Give a very brief answer. 1. What is the ratio of the Emissions(in percent) in New Caledonia in 1994 to that in 1997?
Keep it short and to the point. 0.89. What is the ratio of the Emissions(in percent) in Vietnam in 1994 to that in 1997?
Your answer should be compact. 1.21. What is the ratio of the Emissions(in percent) of Bosnia and Herzegovina in 1994 to that in 1998?
Give a very brief answer. 2.45. What is the ratio of the Emissions(in percent) in Cayman Islands in 1994 to that in 1998?
Give a very brief answer. 1. What is the ratio of the Emissions(in percent) in New Caledonia in 1994 to that in 1998?
Ensure brevity in your answer.  0.87. What is the ratio of the Emissions(in percent) of Vietnam in 1994 to that in 1998?
Give a very brief answer. 1.23. What is the ratio of the Emissions(in percent) in Bosnia and Herzegovina in 1995 to that in 1996?
Provide a succinct answer. 1.2. What is the ratio of the Emissions(in percent) in New Caledonia in 1995 to that in 1996?
Ensure brevity in your answer.  1. What is the ratio of the Emissions(in percent) in Vietnam in 1995 to that in 1996?
Your answer should be compact. 0.98. What is the ratio of the Emissions(in percent) in Bosnia and Herzegovina in 1995 to that in 1997?
Offer a very short reply. 2.3. What is the ratio of the Emissions(in percent) of Cayman Islands in 1995 to that in 1997?
Provide a short and direct response. 1. What is the ratio of the Emissions(in percent) in New Caledonia in 1995 to that in 1997?
Offer a terse response. 0.89. What is the ratio of the Emissions(in percent) of Vietnam in 1995 to that in 1997?
Your answer should be very brief. 1.11. What is the ratio of the Emissions(in percent) of Bosnia and Herzegovina in 1995 to that in 1998?
Your response must be concise. 2.38. What is the ratio of the Emissions(in percent) in New Caledonia in 1995 to that in 1998?
Provide a succinct answer. 0.87. What is the ratio of the Emissions(in percent) in Vietnam in 1995 to that in 1998?
Provide a succinct answer. 1.13. What is the ratio of the Emissions(in percent) in Bosnia and Herzegovina in 1996 to that in 1997?
Your response must be concise. 1.91. What is the ratio of the Emissions(in percent) of New Caledonia in 1996 to that in 1997?
Your response must be concise. 0.89. What is the ratio of the Emissions(in percent) in Vietnam in 1996 to that in 1997?
Keep it short and to the point. 1.13. What is the ratio of the Emissions(in percent) of Bosnia and Herzegovina in 1996 to that in 1998?
Offer a very short reply. 1.97. What is the ratio of the Emissions(in percent) in New Caledonia in 1996 to that in 1998?
Offer a very short reply. 0.87. What is the ratio of the Emissions(in percent) of Vietnam in 1996 to that in 1998?
Ensure brevity in your answer.  1.15. What is the ratio of the Emissions(in percent) of Bosnia and Herzegovina in 1997 to that in 1998?
Your response must be concise. 1.03. What is the ratio of the Emissions(in percent) of New Caledonia in 1997 to that in 1998?
Give a very brief answer. 0.98. What is the ratio of the Emissions(in percent) of Vietnam in 1997 to that in 1998?
Offer a very short reply. 1.02. What is the difference between the highest and the second highest Emissions(in percent) in Bosnia and Herzegovina?
Make the answer very short. 1.6. What is the difference between the highest and the second highest Emissions(in percent) of New Caledonia?
Your answer should be compact. 1.59. What is the difference between the highest and the second highest Emissions(in percent) of Vietnam?
Provide a short and direct response. 2.75. What is the difference between the highest and the lowest Emissions(in percent) in Bosnia and Herzegovina?
Keep it short and to the point. 29.59. What is the difference between the highest and the lowest Emissions(in percent) in Cayman Islands?
Your response must be concise. 0. What is the difference between the highest and the lowest Emissions(in percent) of New Caledonia?
Offer a terse response. 10.71. What is the difference between the highest and the lowest Emissions(in percent) of Vietnam?
Offer a terse response. 12.49. 